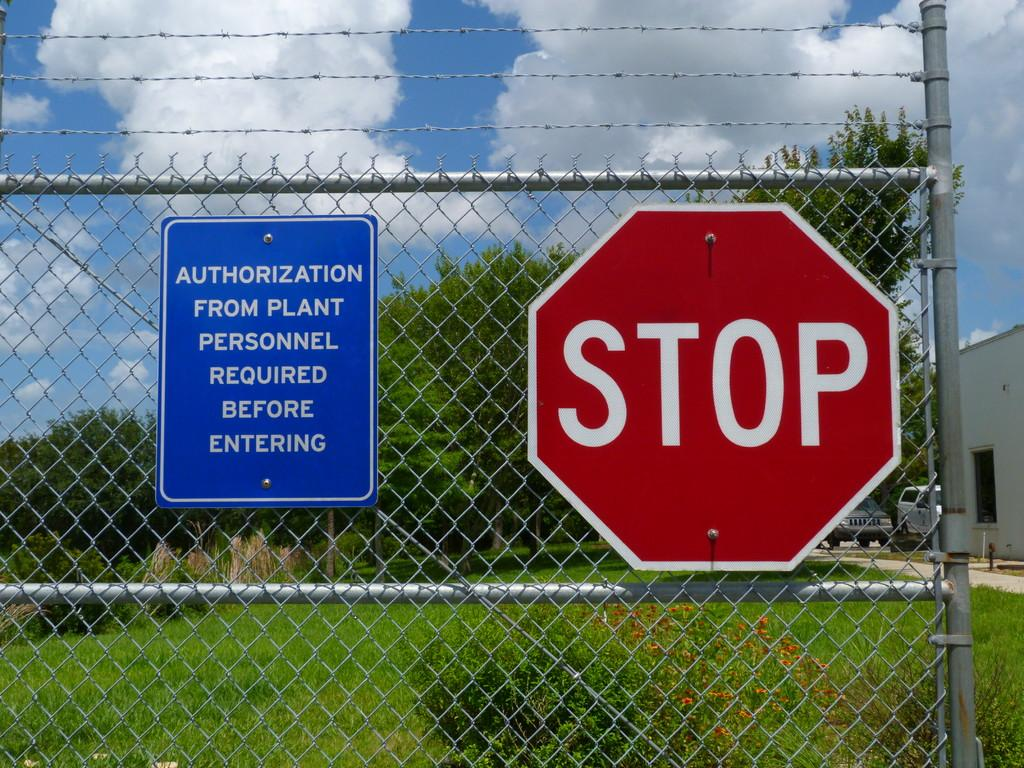<image>
Present a compact description of the photo's key features. A sign on a chain link fence warns visitors that they must have authorization from plant personnel before entering. 